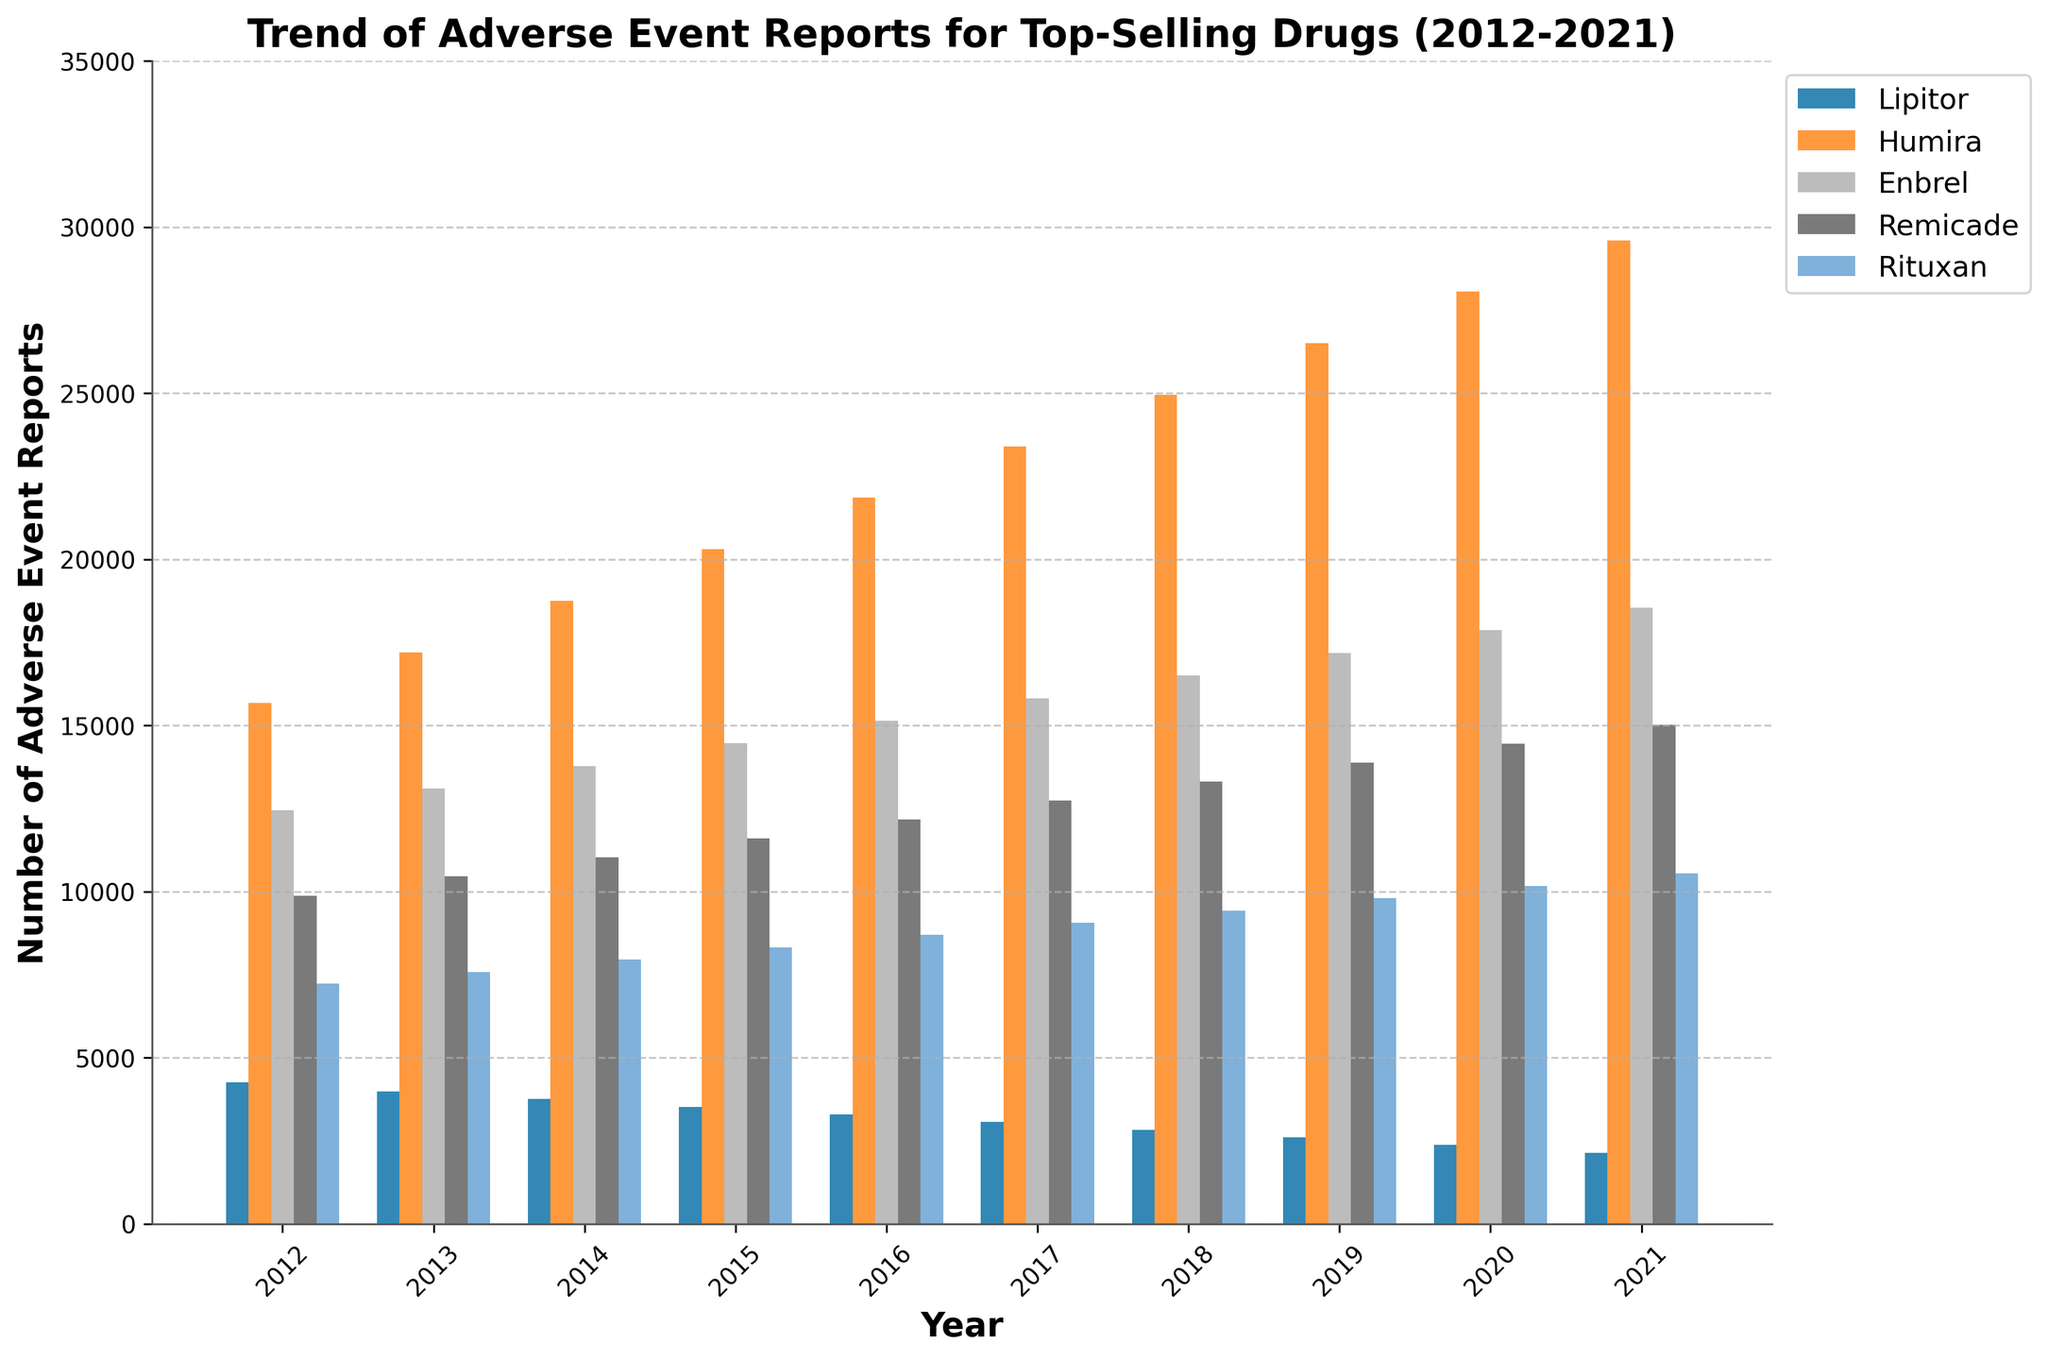What trend can be observed for adverse event reports for Humira from 2012 to 2021? The number of adverse event reports for Humira shows a consistent increase every year from 2012 (15,680 reports) to 2021 (29,600 reports). This is evident from the visual trend of the heights of the bars associated with Humira increasing each year.
Answer: Consistent increase In which year did Enbrel have the highest number of adverse event reports? Looking at the bar heights for Enbrel, the year with the highest bar is 2021, indicating it had the most adverse event reports in that year compared to other years.
Answer: 2021 How does the number of adverse event reports for Remicade in 2015 compare to Lipitor in 2020? In 2015, Remicade had approximately 11,590 adverse event reports, whereas Lipitor had 2,370 adverse event reports in 2020. By comparing the heights of these bars, you can see that Remicade had significantly more reports than Lipitor in the respective years.
Answer: Remicade had more What is the total number of adverse event reports for Rituxan over the entire decade shown? To find the total, sum the given values: 7,230 + 7,580 + 7,950 + 8,320 + 8,690 + 9,060 + 9,430 + 9,800 + 10,170 + 10,540. Adding these values yields 88,770.
Answer: 88,770 Which drug had the least number of adverse event reports in 2012 and how many were reported? By comparing the bar heights for 2012, Lipitor has the shortest bar, indicating it had the least reports with 4,250.
Answer: Lipitor, 4,250 By approximately how much did the number of adverse event reports for Humira increase from 2012 to 2018? The number of adverse event reports for Humira in 2012 was 15,680, and in 2018 it was 24,950. Subtracting these values gives an increase of approximately 9,270 reports.
Answer: Approximately 9,270 In which year does Lipitor's number of adverse event reports become lower than 3,000, and how does the number compare to 2016? Lipitor's reports drop below 3,000 first in 2017 with 3,060, and further drop to 2,830 in 2018. Compared to 3,290 reports in 2016, we can see the reduction was considerable.
Answer: 2017; less What is the average number of adverse event reports for Enbrel in the last 5 years? The adverse event reports for Enbrel from 2017-2021 are 15,820, 16,500, 17,180, 17,860, and 18,540 respectively. Summing these gives 85,900, and dividing by 5 results in an average of 17,180.
Answer: 17,180 How much did the number of adverse event reports for Remicade change from 2013 to 2020? Remicade had 10,450 adverse event reports in 2013 and 14,440 adverse event reports in 2020. The change is found by subtracting the former from the latter, yielding 3,990.
Answer: Increased by 3,990 What is the difference between the sum of adverse event reports for Lipitor and Rituxan in 2014? Summing their reports: Lipitor (3,750) + Rituxan (7,950) equals a total of 11,700 adverse event reports in 2014 for both drugs combined.
Answer: 11,700 